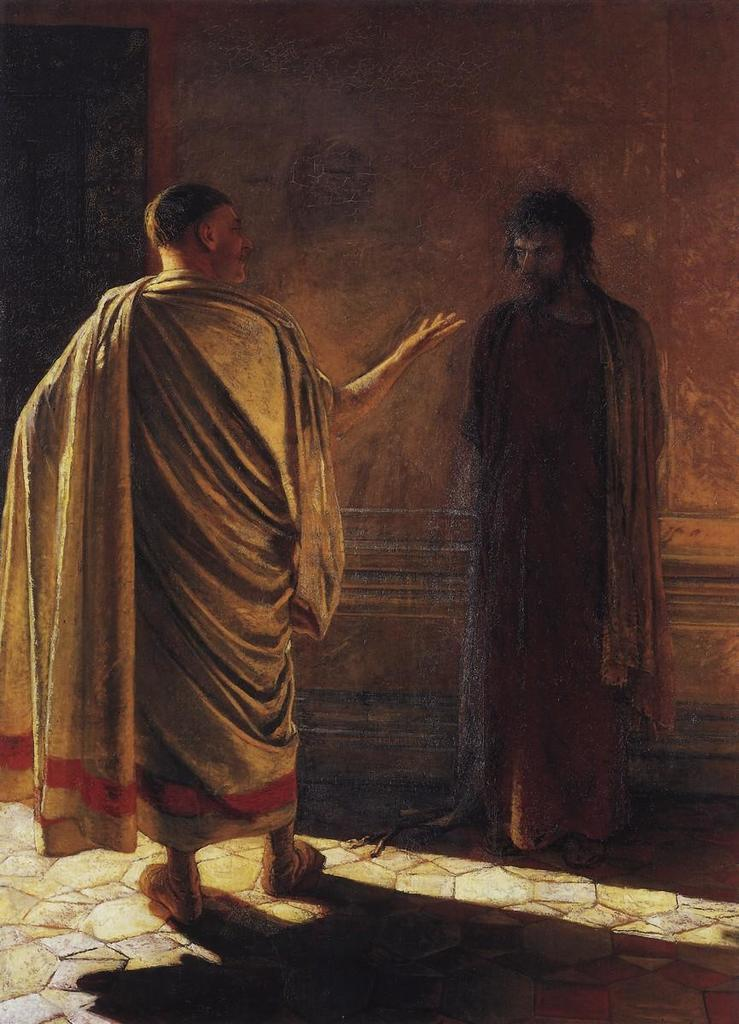What is the main subject of the image? The main subject of the image is a statue of persons. Can you describe the position of the persons in the statue? The persons in the statue are standing near a wall. What other architectural feature can be seen in the image? There is a door visible in the top left corner of the image. Where is the nest of the bird in the image? There is no bird or nest present in the image. What year is depicted in the image? The image does not depict a specific year; it features a statue of persons standing near a wall. 